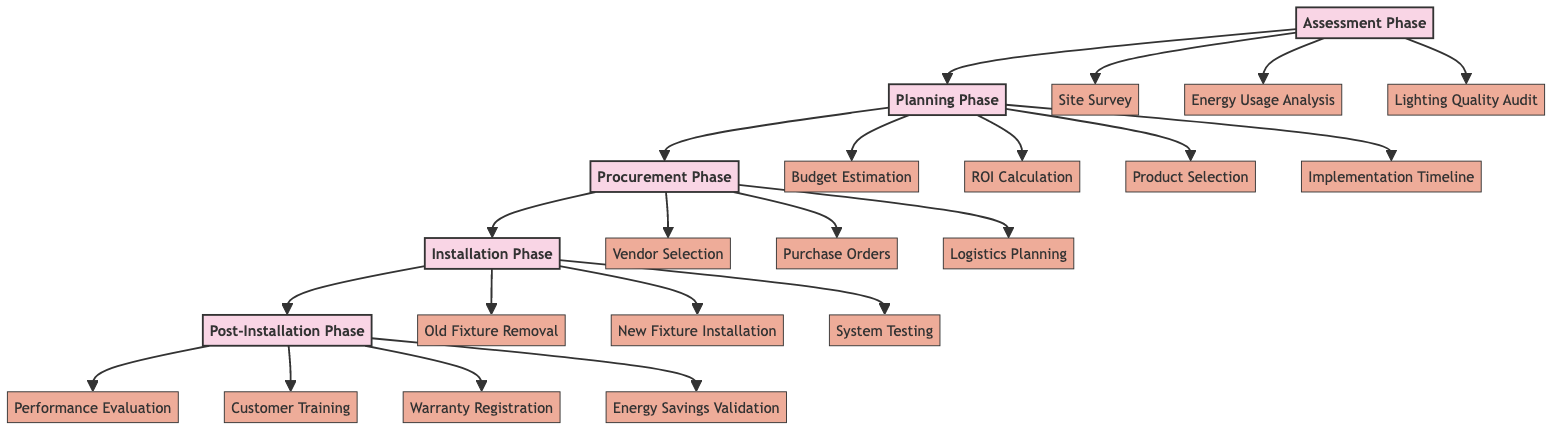What is the first phase of the LED Lighting Conversion Plan? The diagram starts with the "Assessment Phase." It indicates that this phase is the initial step in the process before moving on to subsequent phases.
Answer: Assessment Phase How many phases are there in the LED Lighting Conversion Plan? The diagram shows a total of five distinct phases, labeled from Assessment to Post-Installation. Each phase is connected sequentially.
Answer: Five What is one component of the Procurement Phase? The Procurement Phase includes several components, and one of them is "Vendor Selection," which is directly linked to the Procurement phase in the diagram.
Answer: Vendor Selection Which phase follows the Installation Phase? The diagram clearly shows that the next phase after the Installation Phase is the Post-Installation Phase, as there is a direct connection from Installation to Post-Installation.
Answer: Post-Installation Phase What is the last component of the Post-Installation Phase? The diagram lists "Energy Savings Validation" as the last component of the Post-Installation Phase, indicating it is the final step for this phase.
Answer: Energy Savings Validation What type of analysis is part of the Assessment Phase? The diagram indicates that "Energy Usage Analysis" is part of the Assessment Phase, making it one of the key components to evaluate current usage.
Answer: Energy Usage Analysis How does the Planning Phase contribute to the LED Lighting Conversion Plan? The Planning Phase creates a strategy for the conversion process, including important tasks like "Budget Estimation" and "ROI Calculation," which are crucial for financial planning.
Answer: Budget Estimation, ROI Calculation What are the components of the Installation Phase? The Installation Phase consists of three main components: "Old Fixture Removal," "New Fixture Installation," and "System Testing," all of which are linked to this phase in the diagram.
Answer: Old Fixture Removal, New Fixture Installation, System Testing What is the primary purpose of the Assessment Phase? The primary purpose of the Assessment Phase is to assess current lighting and energy consumption, setting the stage for planning the conversion process.
Answer: To assess current lighting and energy consumption 